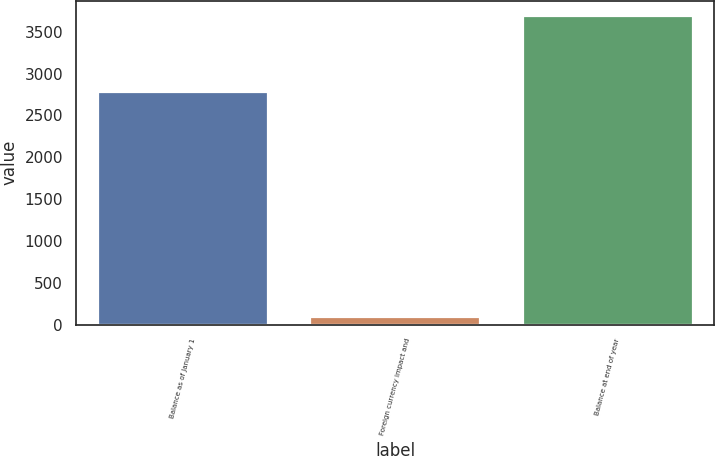<chart> <loc_0><loc_0><loc_500><loc_500><bar_chart><fcel>Balance as of January 1<fcel>Foreign currency impact and<fcel>Balance at end of year<nl><fcel>2779.6<fcel>94.7<fcel>3685.6<nl></chart> 